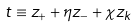<formula> <loc_0><loc_0><loc_500><loc_500>t \equiv z _ { + } + \eta z _ { - } + \chi z _ { k }</formula> 